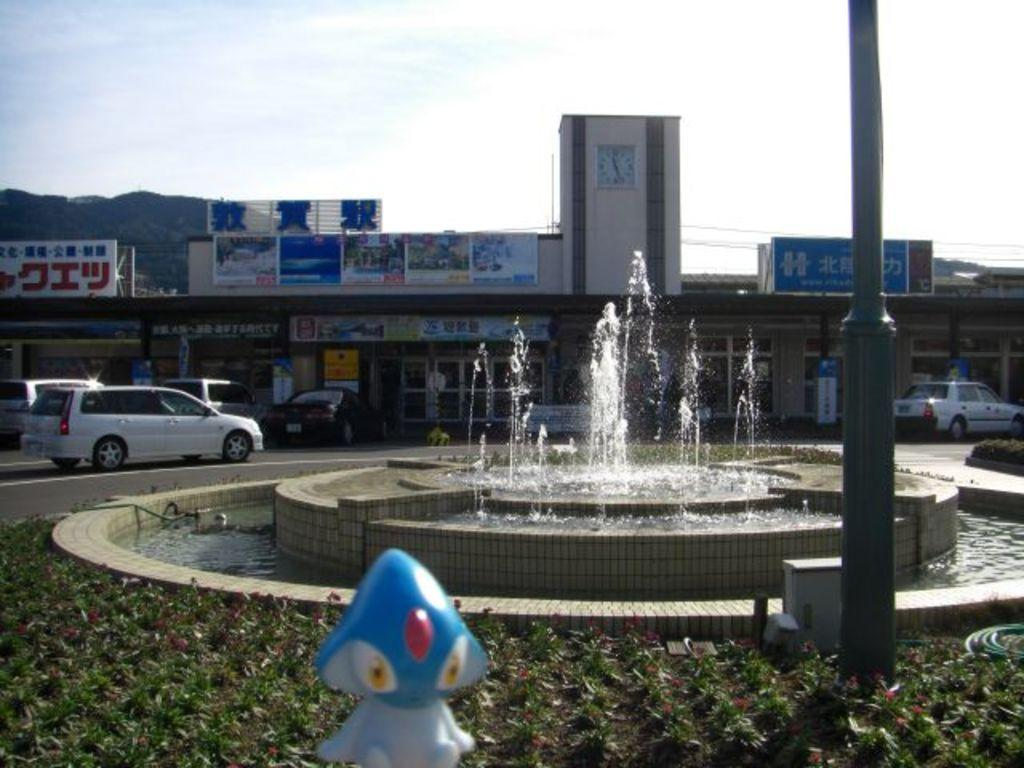What can be seen on the road in the image? There are vehicles on the road in the image. What natural element is visible in the image? There is water visible in the image. What type of structure can be seen in the image? There is a fountain in the image. What architectural feature is present in the image? There is a pole in the image. What type of establishment can be found in the image? There are stores in the image. What time-related object is present in the image? There is a clock in the image. What type of signage is present in the image? There are boards in the image. What geographical feature can be seen in the background of the image? There is a mountain visible in the background. What part of the natural environment is visible in the background of the image? The sky is visible in the background of the image. Can you tell me how many zebras are grazing near the fountain in the image? There are no zebras present in the image; it features vehicles on the road, water, a fountain, a pole, stores, a clock, boards, a mountain, and the sky in the background. What type of bird is perched on the clock in the image? There are no birds visible in the image, including wrens. 